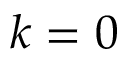Convert formula to latex. <formula><loc_0><loc_0><loc_500><loc_500>k = 0</formula> 